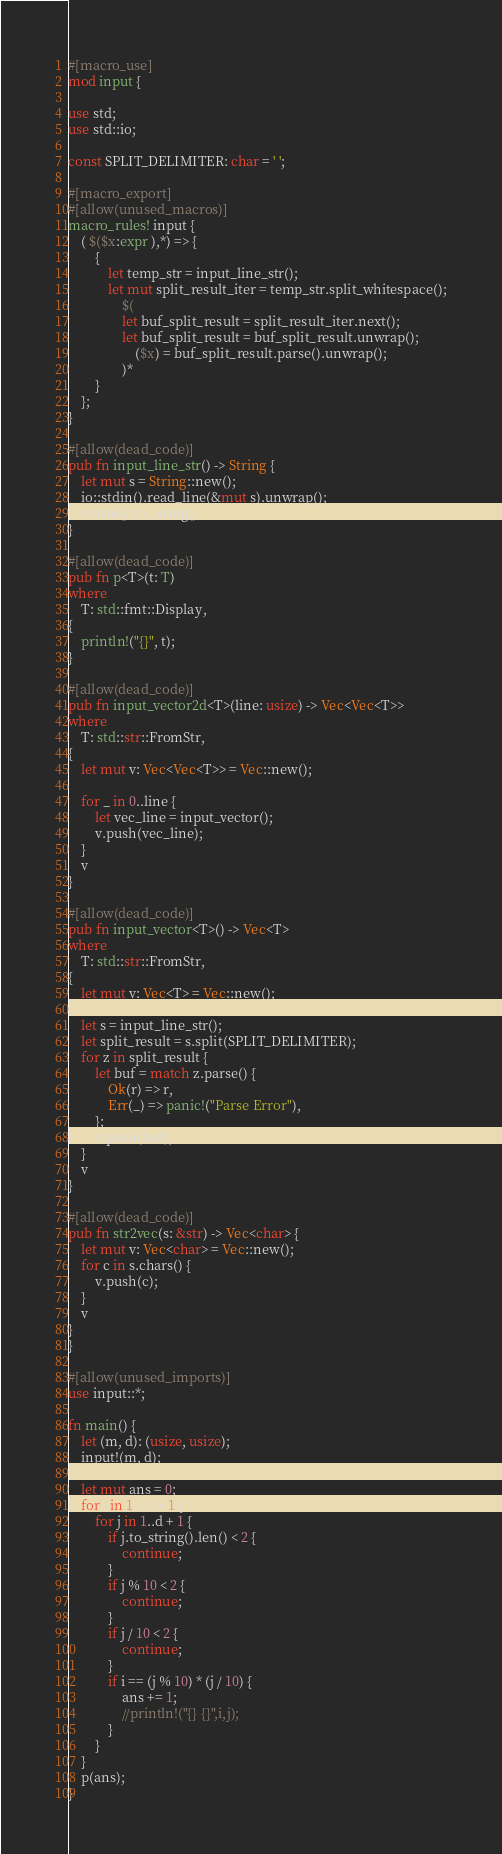Convert code to text. <code><loc_0><loc_0><loc_500><loc_500><_Rust_>#[macro_use]
mod input {

use std;
use std::io;

const SPLIT_DELIMITER: char = ' ';

#[macro_export]
#[allow(unused_macros)]
macro_rules! input {
    ( $($x:expr ),*) => {
        {
            let temp_str = input_line_str();
            let mut split_result_iter = temp_str.split_whitespace();
                $(
                let buf_split_result = split_result_iter.next();
                let buf_split_result = buf_split_result.unwrap();
                    ($x) = buf_split_result.parse().unwrap();
                )*
        }
    };
}

#[allow(dead_code)]
pub fn input_line_str() -> String {
    let mut s = String::new();
    io::stdin().read_line(&mut s).unwrap();
    s.trim().to_string()
}

#[allow(dead_code)]
pub fn p<T>(t: T)
where
    T: std::fmt::Display,
{
    println!("{}", t);
}

#[allow(dead_code)]
pub fn input_vector2d<T>(line: usize) -> Vec<Vec<T>>
where
    T: std::str::FromStr,
{
    let mut v: Vec<Vec<T>> = Vec::new();

    for _ in 0..line {
        let vec_line = input_vector();
        v.push(vec_line);
    }
    v
}

#[allow(dead_code)]
pub fn input_vector<T>() -> Vec<T>
where
    T: std::str::FromStr,
{
    let mut v: Vec<T> = Vec::new();

    let s = input_line_str();
    let split_result = s.split(SPLIT_DELIMITER);
    for z in split_result {
        let buf = match z.parse() {
            Ok(r) => r,
            Err(_) => panic!("Parse Error"),
        };
        v.push(buf);
    }
    v
}

#[allow(dead_code)]
pub fn str2vec(s: &str) -> Vec<char> {
    let mut v: Vec<char> = Vec::new();
    for c in s.chars() {
        v.push(c);
    }
    v
}
}

#[allow(unused_imports)]
use input::*;

fn main() {
    let (m, d): (usize, usize);
    input!(m, d);

    let mut ans = 0;
    for i in 1..m + 1 {
        for j in 1..d + 1 {
            if j.to_string().len() < 2 {
                continue;
            }
            if j % 10 < 2 {
                continue;
            }
            if j / 10 < 2 {
                continue;
            }
            if i == (j % 10) * (j / 10) {
                ans += 1;
                //println!("{} {}",i,j);            
            }
        }
    }
    p(ans);
}
</code> 